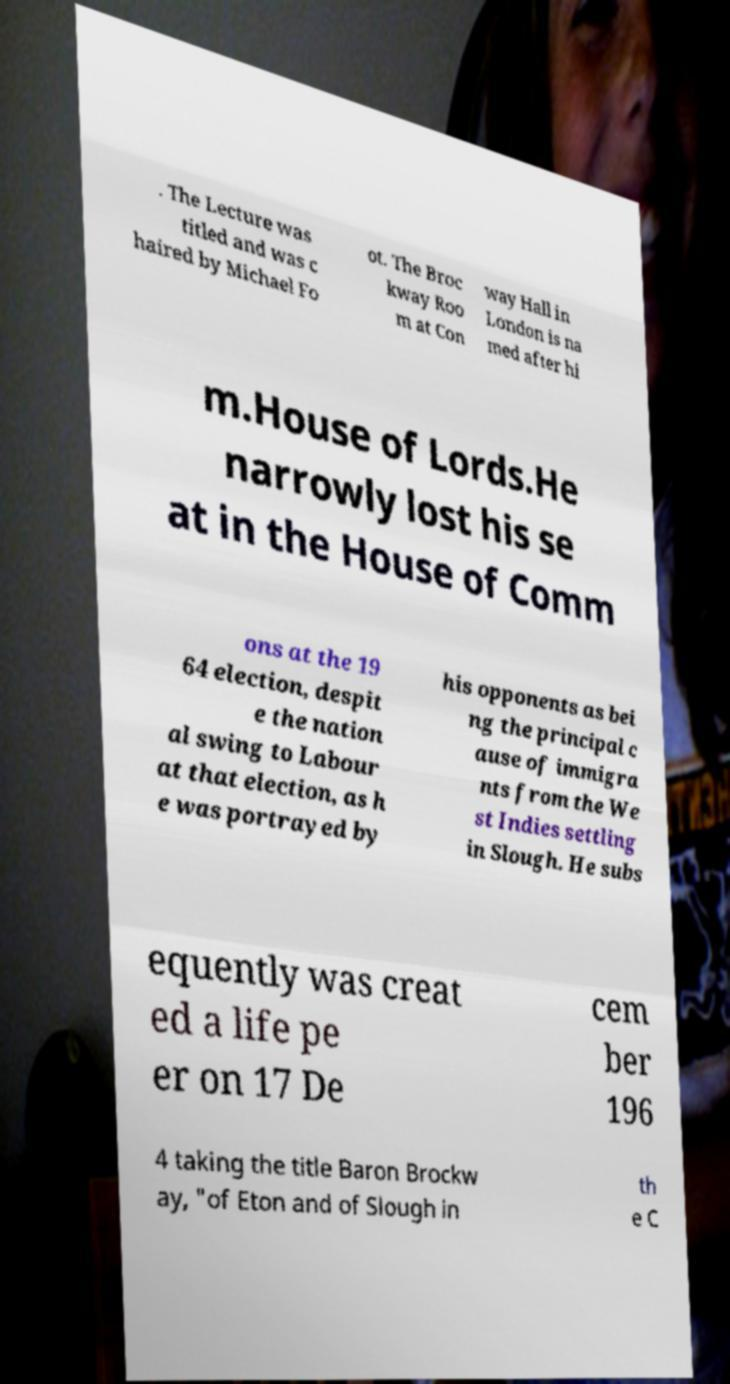For documentation purposes, I need the text within this image transcribed. Could you provide that? . The Lecture was titled and was c haired by Michael Fo ot. The Broc kway Roo m at Con way Hall in London is na med after hi m.House of Lords.He narrowly lost his se at in the House of Comm ons at the 19 64 election, despit e the nation al swing to Labour at that election, as h e was portrayed by his opponents as bei ng the principal c ause of immigra nts from the We st Indies settling in Slough. He subs equently was creat ed a life pe er on 17 De cem ber 196 4 taking the title Baron Brockw ay, "of Eton and of Slough in th e C 